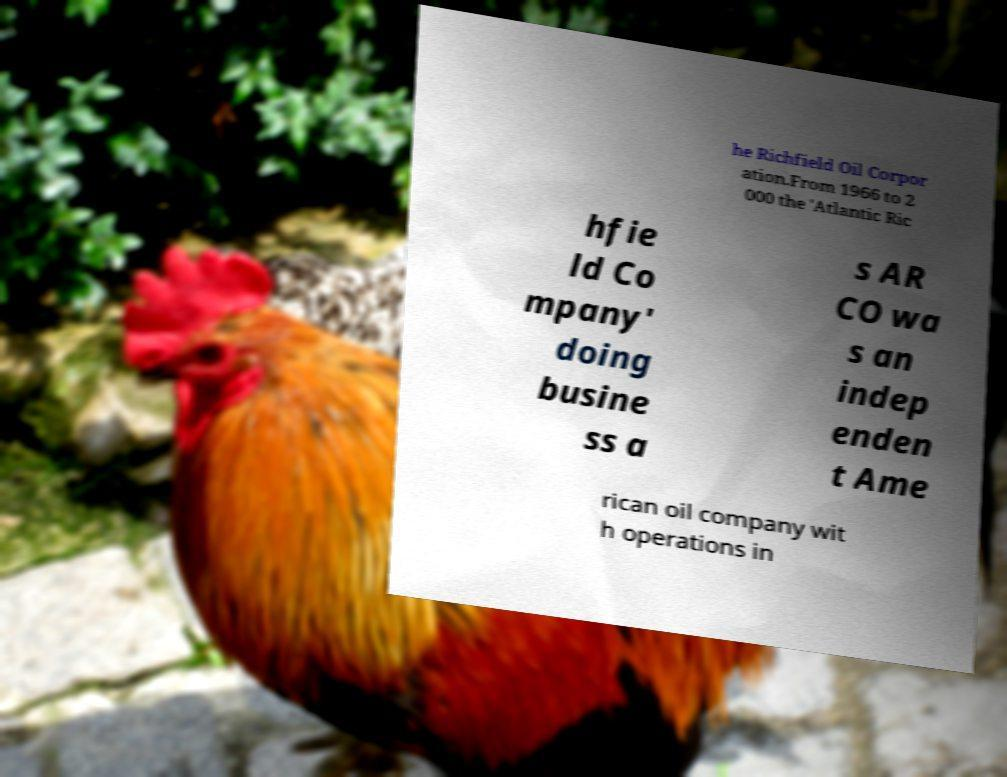Could you extract and type out the text from this image? he Richfield Oil Corpor ation.From 1966 to 2 000 the 'Atlantic Ric hfie ld Co mpany' doing busine ss a s AR CO wa s an indep enden t Ame rican oil company wit h operations in 